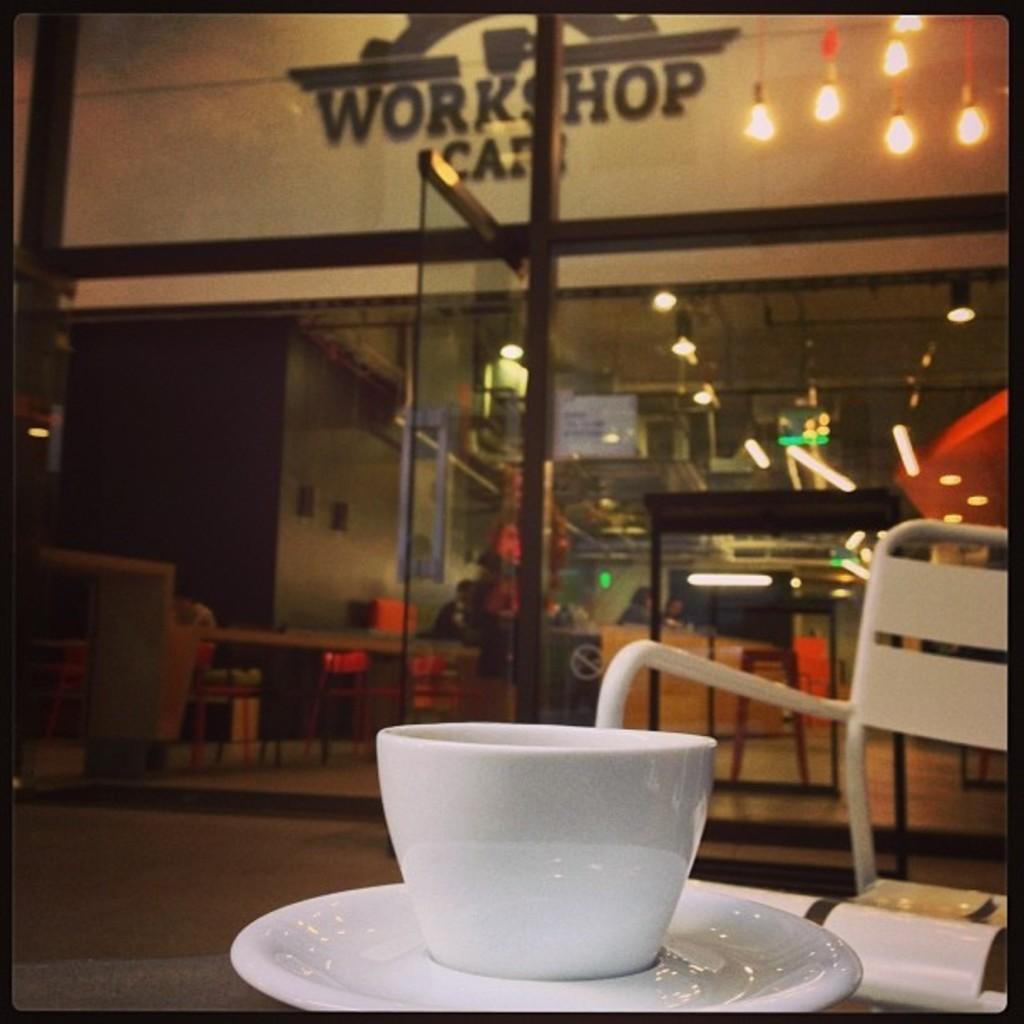What is the name of the cafe?
Offer a very short reply. Workshop cafe. 